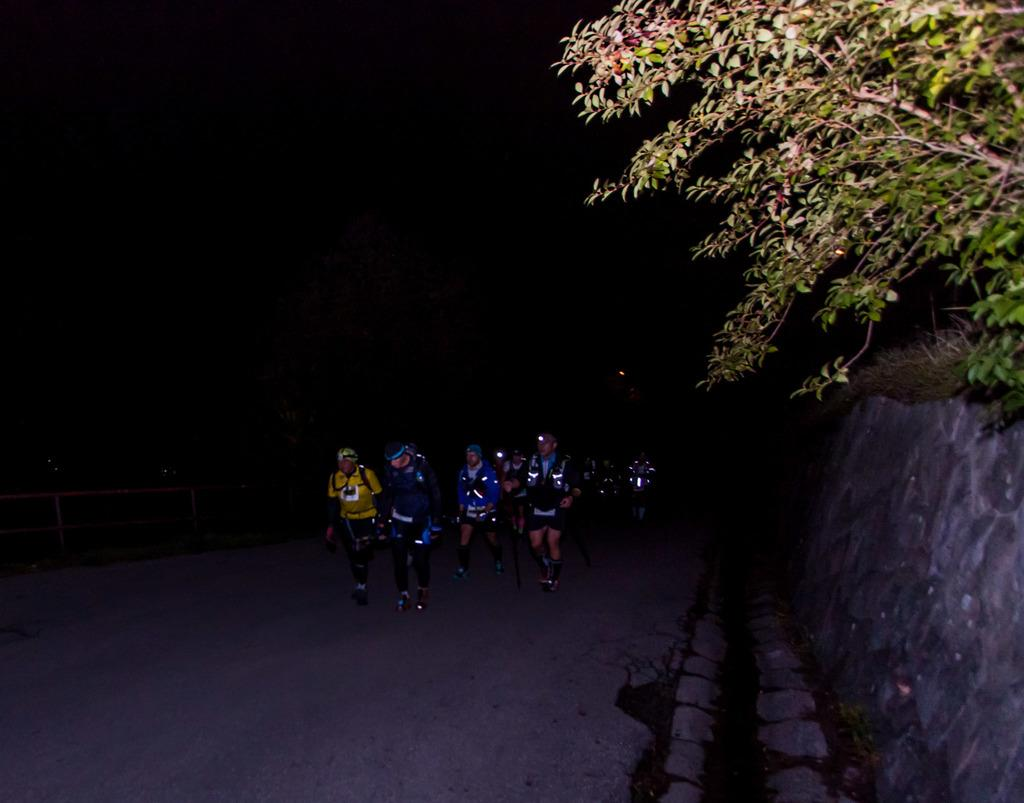How many people are in the image? There is a group of people in the image. What are the people wearing on their heads? The people are wearing helmets. What are the people doing in the image? The people are walking on the road. What type of vegetation can be seen in the image? There are trees in the image. What structures are present in the image? There is a wall and a fence in the image. How would you describe the lighting in the image? The background of the image is dark. What type of flower is being sold at the shop in the image? There is no shop present in the image, so it is not possible to determine what type of flower might be sold there. 